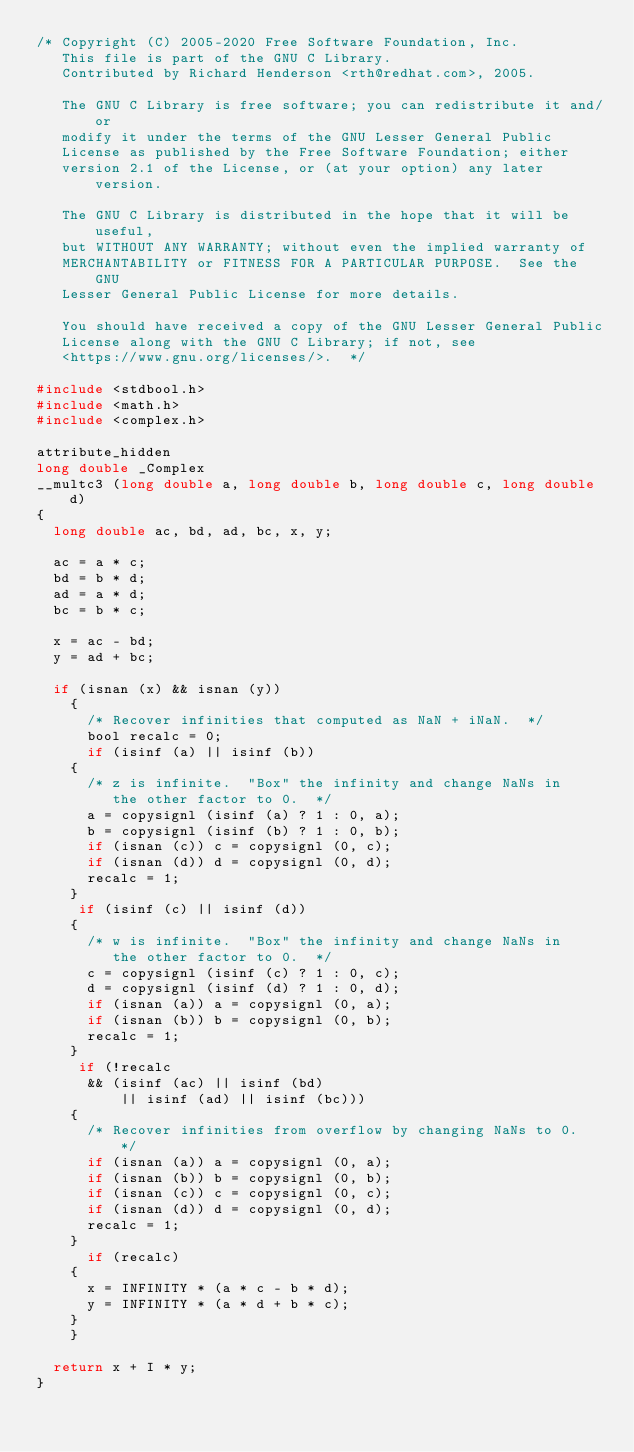Convert code to text. <code><loc_0><loc_0><loc_500><loc_500><_C_>/* Copyright (C) 2005-2020 Free Software Foundation, Inc.
   This file is part of the GNU C Library.
   Contributed by Richard Henderson <rth@redhat.com>, 2005.

   The GNU C Library is free software; you can redistribute it and/or
   modify it under the terms of the GNU Lesser General Public
   License as published by the Free Software Foundation; either
   version 2.1 of the License, or (at your option) any later version.

   The GNU C Library is distributed in the hope that it will be useful,
   but WITHOUT ANY WARRANTY; without even the implied warranty of
   MERCHANTABILITY or FITNESS FOR A PARTICULAR PURPOSE.  See the GNU
   Lesser General Public License for more details.

   You should have received a copy of the GNU Lesser General Public
   License along with the GNU C Library; if not, see
   <https://www.gnu.org/licenses/>.  */

#include <stdbool.h>
#include <math.h>
#include <complex.h>

attribute_hidden
long double _Complex
__multc3 (long double a, long double b, long double c, long double d)
{
  long double ac, bd, ad, bc, x, y;

  ac = a * c;
  bd = b * d;
  ad = a * d;
  bc = b * c;

  x = ac - bd;
  y = ad + bc;

  if (isnan (x) && isnan (y))
    {
      /* Recover infinities that computed as NaN + iNaN.  */
      bool recalc = 0;
      if (isinf (a) || isinf (b))
	{
	  /* z is infinite.  "Box" the infinity and change NaNs in
	     the other factor to 0.  */
	  a = copysignl (isinf (a) ? 1 : 0, a);
	  b = copysignl (isinf (b) ? 1 : 0, b);
	  if (isnan (c)) c = copysignl (0, c);
	  if (isnan (d)) d = copysignl (0, d);
	  recalc = 1;
	}
     if (isinf (c) || isinf (d))
	{
	  /* w is infinite.  "Box" the infinity and change NaNs in
	     the other factor to 0.  */
	  c = copysignl (isinf (c) ? 1 : 0, c);
	  d = copysignl (isinf (d) ? 1 : 0, d);
	  if (isnan (a)) a = copysignl (0, a);
	  if (isnan (b)) b = copysignl (0, b);
	  recalc = 1;
	}
     if (!recalc
	  && (isinf (ac) || isinf (bd)
	      || isinf (ad) || isinf (bc)))
	{
	  /* Recover infinities from overflow by changing NaNs to 0.  */
	  if (isnan (a)) a = copysignl (0, a);
	  if (isnan (b)) b = copysignl (0, b);
	  if (isnan (c)) c = copysignl (0, c);
	  if (isnan (d)) d = copysignl (0, d);
	  recalc = 1;
	}
      if (recalc)
	{
	  x = INFINITY * (a * c - b * d);
	  y = INFINITY * (a * d + b * c);
	}
    }

  return x + I * y;
}
</code> 